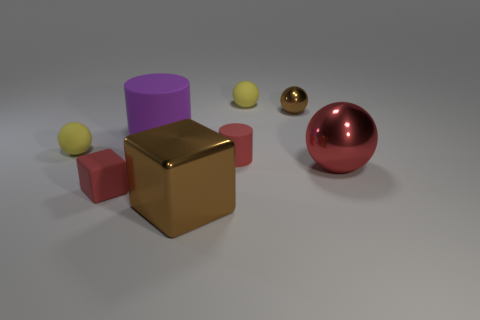Is there a small block of the same color as the small cylinder?
Provide a succinct answer. Yes. What is the color of the metal object that is the same size as the red rubber block?
Keep it short and to the point. Brown. What is the cylinder left of the tiny red thing that is behind the block on the left side of the large purple cylinder made of?
Offer a terse response. Rubber. There is a tiny matte cylinder; does it have the same color as the matte cylinder that is to the left of the large brown cube?
Your answer should be very brief. No. What number of things are either balls that are in front of the purple matte cylinder or small balls behind the large matte cylinder?
Your answer should be compact. 4. What is the shape of the shiny thing behind the yellow matte object on the left side of the big shiny block?
Your answer should be compact. Sphere. Is there a large yellow cylinder that has the same material as the big cube?
Offer a terse response. No. There is a tiny metallic thing that is the same shape as the large red metallic object; what is its color?
Provide a succinct answer. Brown. Is the number of yellow objects that are behind the purple thing less than the number of large red balls that are to the left of the big brown metal thing?
Your answer should be very brief. No. How many other objects are the same shape as the tiny shiny thing?
Give a very brief answer. 3. 